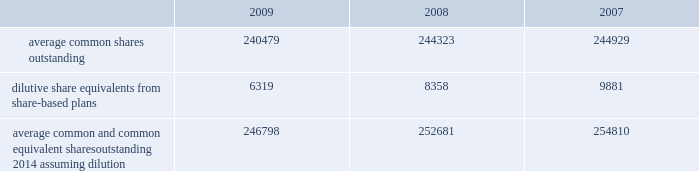The company has a restricted stock plan for non-employee directors which reserves for issuance of 300000 shares of the company 2019s common stock .
No restricted shares were issued in 2009 .
The company has a directors 2019 deferral plan , which provides a means to defer director compensation , from time to time , on a deferred stock or cash basis .
As of september 30 , 2009 , 86643 shares were held in trust , of which 4356 shares represented directors 2019 compensation in 2009 , in accordance with the provisions of the plan .
Under this plan , which is unfunded , directors have an unsecured contractual commitment from the company .
The company also has a deferred compensation plan that allows certain highly-compensated employees , including executive officers , to defer salary , annual incentive awards and certain equity-based compensation .
As of september 30 , 2009 , 557235 shares were issuable under this plan .
Note 16 2014 earnings per share the weighted average common shares used in the computations of basic and diluted earnings per share ( shares in thousands ) for the years ended september 30 were as follows: .
Average common and common equivalent shares outstanding 2014 assuming dilution .
246798 252681 254810 note 17 2014 segment data the company 2019s organizational structure is based upon its three principal business segments : bd medical ( 201cmedical 201d ) , bd diagnostics ( 201cdiagnostics 201d ) and bd biosciences ( 201cbiosciences 201d ) .
The principal product lines in the medical segment include needles , syringes and intravenous catheters for medication delivery ; safety-engineered and auto-disable devices ; prefilled iv flush syringes ; syringes and pen needles for the self-injection of insulin and other drugs used in the treatment of diabetes ; prefillable drug delivery devices provided to pharmaceutical companies and sold to end-users as drug/device combinations ; surgical blades/scalpels and regional anesthesia needles and trays ; critical care monitoring devices ; ophthalmic surgical instruments ; and sharps disposal containers .
The principal products and services in the diagnostics segment include integrated systems for specimen collection ; an extensive line of safety-engineered specimen blood collection products and systems ; plated media ; automated blood culturing systems ; molecular testing systems for sexually transmitted diseases and healthcare-associated infections ; microorganism identification and drug susceptibility systems ; liquid-based cytology systems for cervical cancer screening ; and rapid diagnostic assays .
The principal product lines in the biosciences segment include fluorescence activated cell sorters and analyzers ; cell imaging systems ; monoclonal antibodies and kits for performing cell analysis ; reagent systems for life sciences research ; tools to aid in drug discovery and growth of tissue and cells ; cell culture media supplements for biopharmaceutical manufacturing ; and diagnostic assays .
The company evaluates performance of its business segments based upon operating income .
Segment operating income represents revenues reduced by product costs and operating expenses .
The company hedges against certain forecasted sales of u.s.-produced products sold outside the united states .
Gains and losses associated with these foreign currency translation hedges are reported in segment revenues based upon their proportionate share of these international sales of u.s.-produced products .
Becton , dickinson and company notes to consolidated financial statements 2014 ( continued ) .
As of september 30 , 2009 , what percentage of trust-held shares represented directors' compensation? 
Computations: (4356 / 86643)
Answer: 0.05028. 